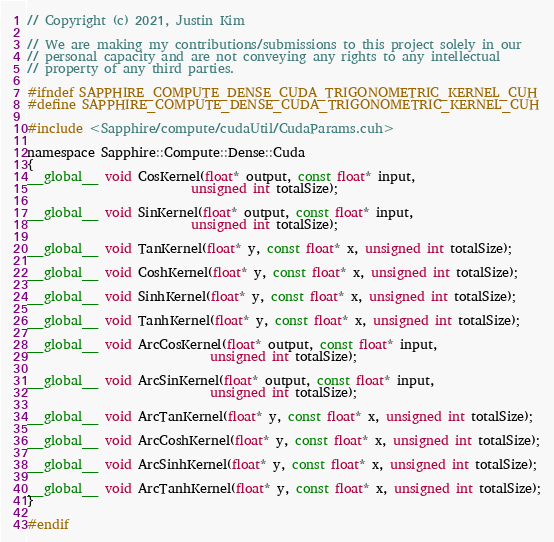Convert code to text. <code><loc_0><loc_0><loc_500><loc_500><_Cuda_>// Copyright (c) 2021, Justin Kim

// We are making my contributions/submissions to this project solely in our
// personal capacity and are not conveying any rights to any intellectual
// property of any third parties.

#ifndef SAPPHIRE_COMPUTE_DENSE_CUDA_TRIGONOMETRIC_KERNEL_CUH
#define SAPPHIRE_COMPUTE_DENSE_CUDA_TRIGONOMETRIC_KERNEL_CUH

#include <Sapphire/compute/cudaUtil/CudaParams.cuh>

namespace Sapphire::Compute::Dense::Cuda
{
__global__ void CosKernel(float* output, const float* input,
                          unsigned int totalSize);

__global__ void SinKernel(float* output, const float* input,
                          unsigned int totalSize);

__global__ void TanKernel(float* y, const float* x, unsigned int totalSize);

__global__ void CoshKernel(float* y, const float* x, unsigned int totalSize);

__global__ void SinhKernel(float* y, const float* x, unsigned int totalSize);

__global__ void TanhKernel(float* y, const float* x, unsigned int totalSize);

__global__ void ArcCosKernel(float* output, const float* input,
                             unsigned int totalSize);

__global__ void ArcSinKernel(float* output, const float* input,
                             unsigned int totalSize);

__global__ void ArcTanKernel(float* y, const float* x, unsigned int totalSize);

__global__ void ArcCoshKernel(float* y, const float* x, unsigned int totalSize);

__global__ void ArcSinhKernel(float* y, const float* x, unsigned int totalSize);

__global__ void ArcTanhKernel(float* y, const float* x, unsigned int totalSize);
}

#endif
</code> 